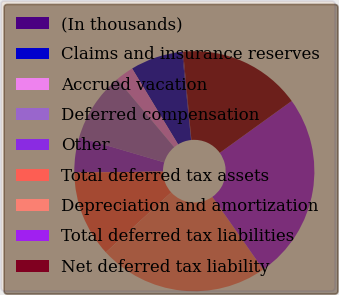<chart> <loc_0><loc_0><loc_500><loc_500><pie_chart><fcel>(In thousands)<fcel>Claims and insurance reserves<fcel>Accrued vacation<fcel>Deferred compensation<fcel>Other<fcel>Total deferred tax assets<fcel>Depreciation and amortization<fcel>Total deferred tax liabilities<fcel>Net deferred tax liability<nl><fcel>0.14%<fcel>7.04%<fcel>2.44%<fcel>9.34%<fcel>4.74%<fcel>11.63%<fcel>22.92%<fcel>25.22%<fcel>16.55%<nl></chart> 